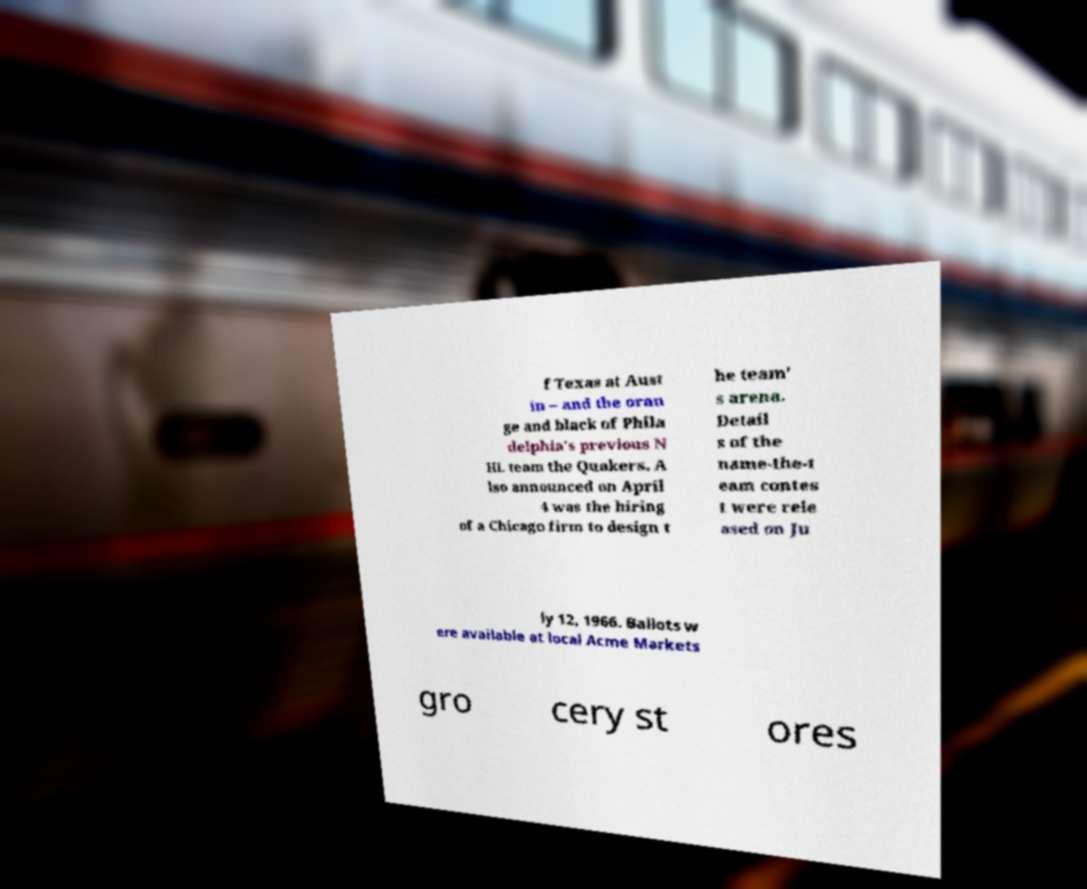Please read and relay the text visible in this image. What does it say? f Texas at Aust in – and the oran ge and black of Phila delphia's previous N HL team the Quakers. A lso announced on April 4 was the hiring of a Chicago firm to design t he team' s arena. Detail s of the name-the-t eam contes t were rele ased on Ju ly 12, 1966. Ballots w ere available at local Acme Markets gro cery st ores 